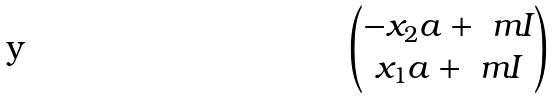<formula> <loc_0><loc_0><loc_500><loc_500>\begin{pmatrix} - x _ { 2 } a + \ m I \\ x _ { 1 } a + \ m I \end{pmatrix}</formula> 